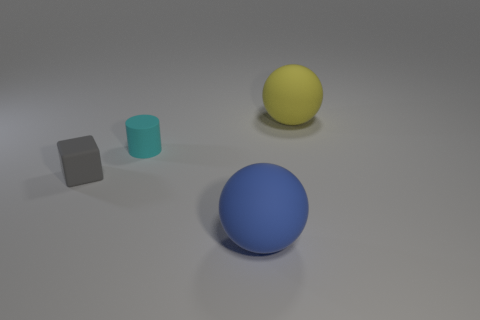Add 2 gray metallic things. How many objects exist? 6 Subtract all cylinders. How many objects are left? 3 Subtract 0 red balls. How many objects are left? 4 Subtract all red metallic cylinders. Subtract all large yellow matte objects. How many objects are left? 3 Add 1 small matte objects. How many small matte objects are left? 3 Add 3 spheres. How many spheres exist? 5 